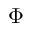<formula> <loc_0><loc_0><loc_500><loc_500>\Phi</formula> 